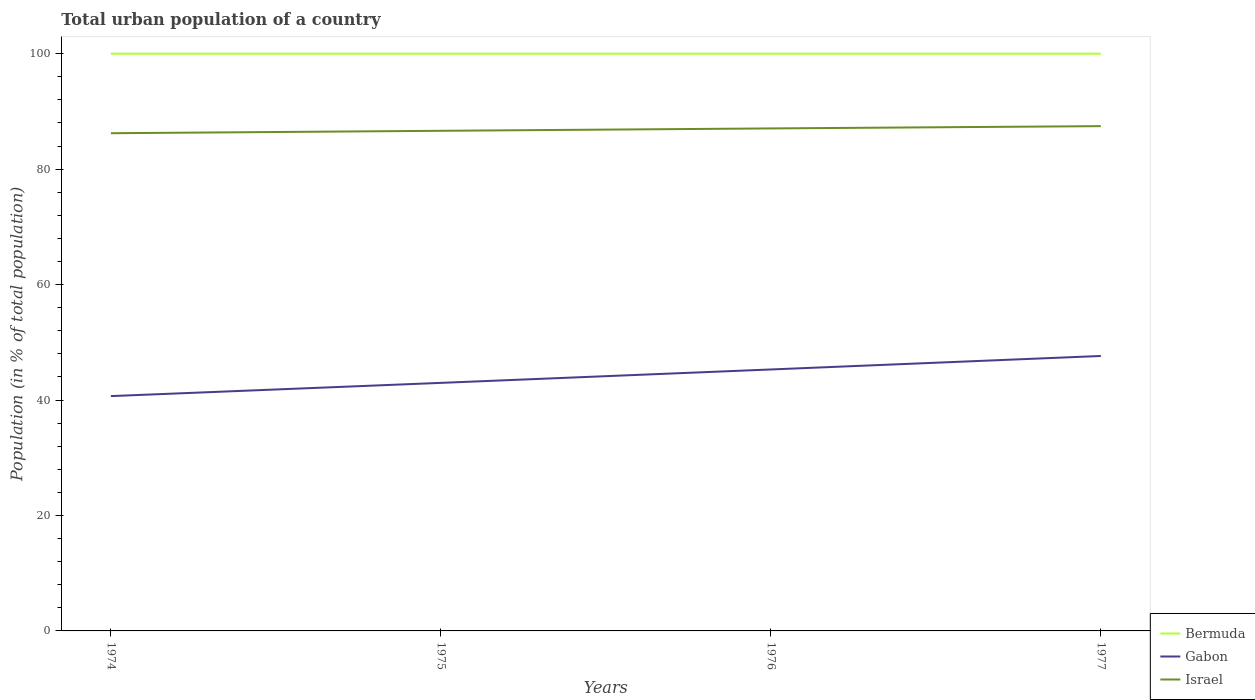How many different coloured lines are there?
Give a very brief answer. 3. Does the line corresponding to Gabon intersect with the line corresponding to Israel?
Make the answer very short. No. Is the number of lines equal to the number of legend labels?
Your answer should be very brief. Yes. Across all years, what is the maximum urban population in Israel?
Provide a succinct answer. 86.22. In which year was the urban population in Gabon maximum?
Your answer should be compact. 1974. What is the total urban population in Israel in the graph?
Make the answer very short. -0.81. What is the difference between the highest and the second highest urban population in Gabon?
Offer a terse response. 6.95. What is the difference between the highest and the lowest urban population in Bermuda?
Provide a succinct answer. 0. How many years are there in the graph?
Provide a short and direct response. 4. Does the graph contain grids?
Provide a short and direct response. No. Where does the legend appear in the graph?
Provide a short and direct response. Bottom right. What is the title of the graph?
Offer a terse response. Total urban population of a country. Does "South Sudan" appear as one of the legend labels in the graph?
Provide a succinct answer. No. What is the label or title of the Y-axis?
Provide a short and direct response. Population (in % of total population). What is the Population (in % of total population) in Gabon in 1974?
Offer a very short reply. 40.68. What is the Population (in % of total population) of Israel in 1974?
Provide a succinct answer. 86.22. What is the Population (in % of total population) of Bermuda in 1975?
Make the answer very short. 100. What is the Population (in % of total population) of Gabon in 1975?
Your answer should be compact. 42.97. What is the Population (in % of total population) of Israel in 1975?
Provide a short and direct response. 86.64. What is the Population (in % of total population) in Gabon in 1976?
Provide a short and direct response. 45.3. What is the Population (in % of total population) of Israel in 1976?
Ensure brevity in your answer.  87.05. What is the Population (in % of total population) in Gabon in 1977?
Provide a short and direct response. 47.63. What is the Population (in % of total population) in Israel in 1977?
Offer a very short reply. 87.45. Across all years, what is the maximum Population (in % of total population) in Bermuda?
Offer a very short reply. 100. Across all years, what is the maximum Population (in % of total population) in Gabon?
Offer a very short reply. 47.63. Across all years, what is the maximum Population (in % of total population) in Israel?
Make the answer very short. 87.45. Across all years, what is the minimum Population (in % of total population) of Gabon?
Offer a very short reply. 40.68. Across all years, what is the minimum Population (in % of total population) of Israel?
Ensure brevity in your answer.  86.22. What is the total Population (in % of total population) of Bermuda in the graph?
Make the answer very short. 400. What is the total Population (in % of total population) in Gabon in the graph?
Provide a short and direct response. 176.58. What is the total Population (in % of total population) in Israel in the graph?
Your response must be concise. 347.37. What is the difference between the Population (in % of total population) in Bermuda in 1974 and that in 1975?
Give a very brief answer. 0. What is the difference between the Population (in % of total population) in Gabon in 1974 and that in 1975?
Provide a short and direct response. -2.29. What is the difference between the Population (in % of total population) in Israel in 1974 and that in 1975?
Offer a very short reply. -0.42. What is the difference between the Population (in % of total population) in Bermuda in 1974 and that in 1976?
Ensure brevity in your answer.  0. What is the difference between the Population (in % of total population) in Gabon in 1974 and that in 1976?
Your response must be concise. -4.61. What is the difference between the Population (in % of total population) of Israel in 1974 and that in 1976?
Your answer should be compact. -0.83. What is the difference between the Population (in % of total population) of Bermuda in 1974 and that in 1977?
Your answer should be very brief. 0. What is the difference between the Population (in % of total population) in Gabon in 1974 and that in 1977?
Your answer should be very brief. -6.95. What is the difference between the Population (in % of total population) in Israel in 1974 and that in 1977?
Ensure brevity in your answer.  -1.23. What is the difference between the Population (in % of total population) in Gabon in 1975 and that in 1976?
Your response must be concise. -2.32. What is the difference between the Population (in % of total population) of Israel in 1975 and that in 1976?
Provide a succinct answer. -0.41. What is the difference between the Population (in % of total population) in Bermuda in 1975 and that in 1977?
Offer a very short reply. 0. What is the difference between the Population (in % of total population) in Gabon in 1975 and that in 1977?
Offer a very short reply. -4.66. What is the difference between the Population (in % of total population) of Israel in 1975 and that in 1977?
Your answer should be very brief. -0.81. What is the difference between the Population (in % of total population) of Bermuda in 1976 and that in 1977?
Provide a succinct answer. 0. What is the difference between the Population (in % of total population) of Gabon in 1976 and that in 1977?
Your answer should be very brief. -2.34. What is the difference between the Population (in % of total population) in Israel in 1976 and that in 1977?
Make the answer very short. -0.4. What is the difference between the Population (in % of total population) in Bermuda in 1974 and the Population (in % of total population) in Gabon in 1975?
Your answer should be compact. 57.03. What is the difference between the Population (in % of total population) in Bermuda in 1974 and the Population (in % of total population) in Israel in 1975?
Give a very brief answer. 13.36. What is the difference between the Population (in % of total population) in Gabon in 1974 and the Population (in % of total population) in Israel in 1975?
Ensure brevity in your answer.  -45.96. What is the difference between the Population (in % of total population) of Bermuda in 1974 and the Population (in % of total population) of Gabon in 1976?
Give a very brief answer. 54.7. What is the difference between the Population (in % of total population) of Bermuda in 1974 and the Population (in % of total population) of Israel in 1976?
Your answer should be very brief. 12.95. What is the difference between the Population (in % of total population) of Gabon in 1974 and the Population (in % of total population) of Israel in 1976?
Offer a very short reply. -46.37. What is the difference between the Population (in % of total population) of Bermuda in 1974 and the Population (in % of total population) of Gabon in 1977?
Offer a terse response. 52.37. What is the difference between the Population (in % of total population) of Bermuda in 1974 and the Population (in % of total population) of Israel in 1977?
Your response must be concise. 12.55. What is the difference between the Population (in % of total population) of Gabon in 1974 and the Population (in % of total population) of Israel in 1977?
Your response must be concise. -46.77. What is the difference between the Population (in % of total population) in Bermuda in 1975 and the Population (in % of total population) in Gabon in 1976?
Your response must be concise. 54.7. What is the difference between the Population (in % of total population) of Bermuda in 1975 and the Population (in % of total population) of Israel in 1976?
Your answer should be compact. 12.95. What is the difference between the Population (in % of total population) of Gabon in 1975 and the Population (in % of total population) of Israel in 1976?
Make the answer very short. -44.08. What is the difference between the Population (in % of total population) of Bermuda in 1975 and the Population (in % of total population) of Gabon in 1977?
Keep it short and to the point. 52.37. What is the difference between the Population (in % of total population) in Bermuda in 1975 and the Population (in % of total population) in Israel in 1977?
Your answer should be compact. 12.55. What is the difference between the Population (in % of total population) of Gabon in 1975 and the Population (in % of total population) of Israel in 1977?
Your answer should be compact. -44.48. What is the difference between the Population (in % of total population) in Bermuda in 1976 and the Population (in % of total population) in Gabon in 1977?
Your response must be concise. 52.37. What is the difference between the Population (in % of total population) of Bermuda in 1976 and the Population (in % of total population) of Israel in 1977?
Provide a short and direct response. 12.55. What is the difference between the Population (in % of total population) in Gabon in 1976 and the Population (in % of total population) in Israel in 1977?
Provide a succinct answer. -42.16. What is the average Population (in % of total population) of Bermuda per year?
Keep it short and to the point. 100. What is the average Population (in % of total population) of Gabon per year?
Offer a terse response. 44.15. What is the average Population (in % of total population) in Israel per year?
Ensure brevity in your answer.  86.84. In the year 1974, what is the difference between the Population (in % of total population) in Bermuda and Population (in % of total population) in Gabon?
Your response must be concise. 59.32. In the year 1974, what is the difference between the Population (in % of total population) of Bermuda and Population (in % of total population) of Israel?
Your answer should be very brief. 13.78. In the year 1974, what is the difference between the Population (in % of total population) in Gabon and Population (in % of total population) in Israel?
Keep it short and to the point. -45.54. In the year 1975, what is the difference between the Population (in % of total population) of Bermuda and Population (in % of total population) of Gabon?
Provide a short and direct response. 57.03. In the year 1975, what is the difference between the Population (in % of total population) in Bermuda and Population (in % of total population) in Israel?
Keep it short and to the point. 13.36. In the year 1975, what is the difference between the Population (in % of total population) of Gabon and Population (in % of total population) of Israel?
Provide a succinct answer. -43.67. In the year 1976, what is the difference between the Population (in % of total population) in Bermuda and Population (in % of total population) in Gabon?
Keep it short and to the point. 54.7. In the year 1976, what is the difference between the Population (in % of total population) of Bermuda and Population (in % of total population) of Israel?
Make the answer very short. 12.95. In the year 1976, what is the difference between the Population (in % of total population) of Gabon and Population (in % of total population) of Israel?
Your answer should be compact. -41.76. In the year 1977, what is the difference between the Population (in % of total population) in Bermuda and Population (in % of total population) in Gabon?
Your response must be concise. 52.37. In the year 1977, what is the difference between the Population (in % of total population) in Bermuda and Population (in % of total population) in Israel?
Offer a terse response. 12.55. In the year 1977, what is the difference between the Population (in % of total population) of Gabon and Population (in % of total population) of Israel?
Make the answer very short. -39.82. What is the ratio of the Population (in % of total population) of Bermuda in 1974 to that in 1975?
Keep it short and to the point. 1. What is the ratio of the Population (in % of total population) in Gabon in 1974 to that in 1975?
Offer a terse response. 0.95. What is the ratio of the Population (in % of total population) in Israel in 1974 to that in 1975?
Your answer should be compact. 1. What is the ratio of the Population (in % of total population) of Gabon in 1974 to that in 1976?
Offer a very short reply. 0.9. What is the ratio of the Population (in % of total population) of Israel in 1974 to that in 1976?
Your answer should be compact. 0.99. What is the ratio of the Population (in % of total population) in Gabon in 1974 to that in 1977?
Offer a very short reply. 0.85. What is the ratio of the Population (in % of total population) of Israel in 1974 to that in 1977?
Provide a succinct answer. 0.99. What is the ratio of the Population (in % of total population) of Bermuda in 1975 to that in 1976?
Your answer should be very brief. 1. What is the ratio of the Population (in % of total population) in Gabon in 1975 to that in 1976?
Your answer should be very brief. 0.95. What is the ratio of the Population (in % of total population) in Bermuda in 1975 to that in 1977?
Offer a very short reply. 1. What is the ratio of the Population (in % of total population) in Gabon in 1975 to that in 1977?
Keep it short and to the point. 0.9. What is the ratio of the Population (in % of total population) in Israel in 1975 to that in 1977?
Provide a short and direct response. 0.99. What is the ratio of the Population (in % of total population) in Bermuda in 1976 to that in 1977?
Provide a succinct answer. 1. What is the ratio of the Population (in % of total population) in Gabon in 1976 to that in 1977?
Keep it short and to the point. 0.95. What is the ratio of the Population (in % of total population) in Israel in 1976 to that in 1977?
Provide a short and direct response. 1. What is the difference between the highest and the second highest Population (in % of total population) in Bermuda?
Make the answer very short. 0. What is the difference between the highest and the second highest Population (in % of total population) in Gabon?
Your answer should be very brief. 2.34. What is the difference between the highest and the second highest Population (in % of total population) in Israel?
Keep it short and to the point. 0.4. What is the difference between the highest and the lowest Population (in % of total population) of Bermuda?
Your answer should be compact. 0. What is the difference between the highest and the lowest Population (in % of total population) of Gabon?
Offer a very short reply. 6.95. What is the difference between the highest and the lowest Population (in % of total population) of Israel?
Ensure brevity in your answer.  1.23. 